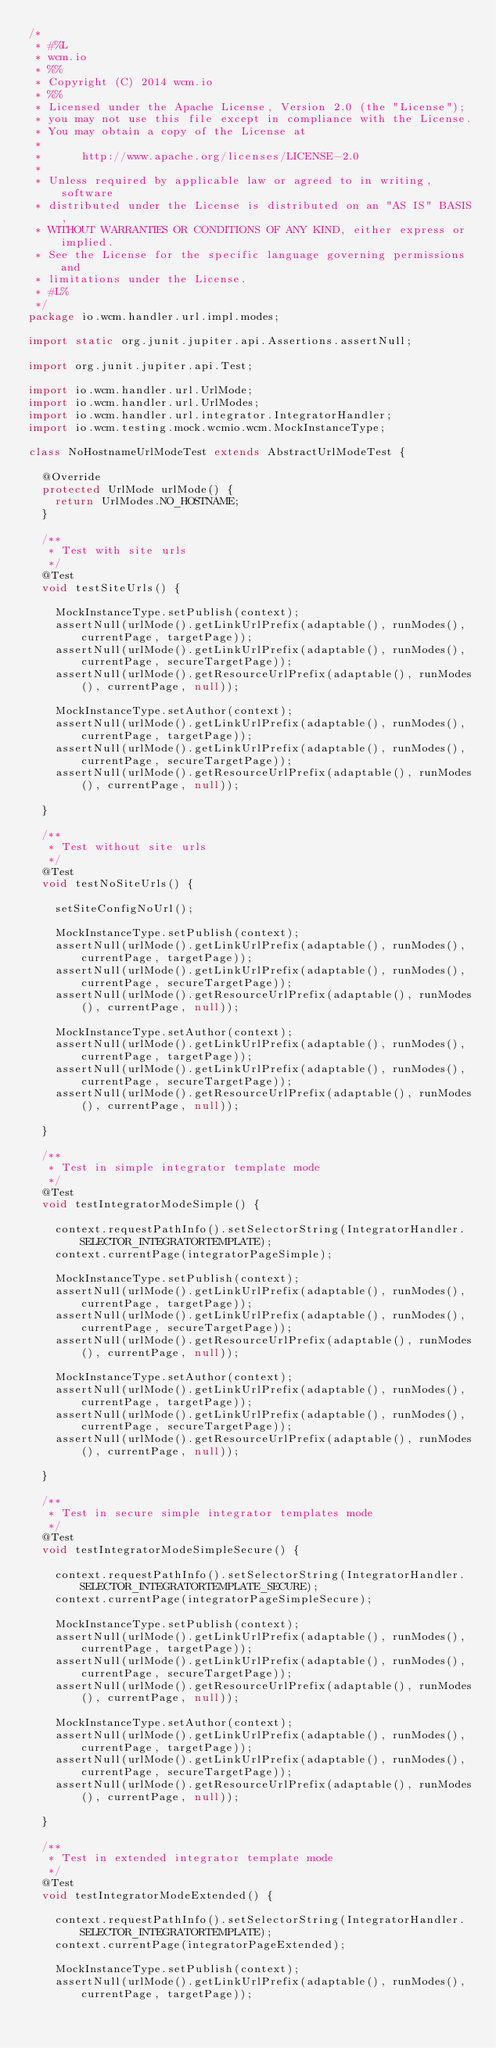Convert code to text. <code><loc_0><loc_0><loc_500><loc_500><_Java_>/*
 * #%L
 * wcm.io
 * %%
 * Copyright (C) 2014 wcm.io
 * %%
 * Licensed under the Apache License, Version 2.0 (the "License");
 * you may not use this file except in compliance with the License.
 * You may obtain a copy of the License at
 *
 *      http://www.apache.org/licenses/LICENSE-2.0
 *
 * Unless required by applicable law or agreed to in writing, software
 * distributed under the License is distributed on an "AS IS" BASIS,
 * WITHOUT WARRANTIES OR CONDITIONS OF ANY KIND, either express or implied.
 * See the License for the specific language governing permissions and
 * limitations under the License.
 * #L%
 */
package io.wcm.handler.url.impl.modes;

import static org.junit.jupiter.api.Assertions.assertNull;

import org.junit.jupiter.api.Test;

import io.wcm.handler.url.UrlMode;
import io.wcm.handler.url.UrlModes;
import io.wcm.handler.url.integrator.IntegratorHandler;
import io.wcm.testing.mock.wcmio.wcm.MockInstanceType;

class NoHostnameUrlModeTest extends AbstractUrlModeTest {

  @Override
  protected UrlMode urlMode() {
    return UrlModes.NO_HOSTNAME;
  }

  /**
   * Test with site urls
   */
  @Test
  void testSiteUrls() {

    MockInstanceType.setPublish(context);
    assertNull(urlMode().getLinkUrlPrefix(adaptable(), runModes(), currentPage, targetPage));
    assertNull(urlMode().getLinkUrlPrefix(adaptable(), runModes(), currentPage, secureTargetPage));
    assertNull(urlMode().getResourceUrlPrefix(adaptable(), runModes(), currentPage, null));

    MockInstanceType.setAuthor(context);
    assertNull(urlMode().getLinkUrlPrefix(adaptable(), runModes(), currentPage, targetPage));
    assertNull(urlMode().getLinkUrlPrefix(adaptable(), runModes(), currentPage, secureTargetPage));
    assertNull(urlMode().getResourceUrlPrefix(adaptable(), runModes(), currentPage, null));

  }

  /**
   * Test without site urls
   */
  @Test
  void testNoSiteUrls() {

    setSiteConfigNoUrl();

    MockInstanceType.setPublish(context);
    assertNull(urlMode().getLinkUrlPrefix(adaptable(), runModes(), currentPage, targetPage));
    assertNull(urlMode().getLinkUrlPrefix(adaptable(), runModes(), currentPage, secureTargetPage));
    assertNull(urlMode().getResourceUrlPrefix(adaptable(), runModes(), currentPage, null));

    MockInstanceType.setAuthor(context);
    assertNull(urlMode().getLinkUrlPrefix(adaptable(), runModes(), currentPage, targetPage));
    assertNull(urlMode().getLinkUrlPrefix(adaptable(), runModes(), currentPage, secureTargetPage));
    assertNull(urlMode().getResourceUrlPrefix(adaptable(), runModes(), currentPage, null));

  }

  /**
   * Test in simple integrator template mode
   */
  @Test
  void testIntegratorModeSimple() {

    context.requestPathInfo().setSelectorString(IntegratorHandler.SELECTOR_INTEGRATORTEMPLATE);
    context.currentPage(integratorPageSimple);

    MockInstanceType.setPublish(context);
    assertNull(urlMode().getLinkUrlPrefix(adaptable(), runModes(), currentPage, targetPage));
    assertNull(urlMode().getLinkUrlPrefix(adaptable(), runModes(), currentPage, secureTargetPage));
    assertNull(urlMode().getResourceUrlPrefix(adaptable(), runModes(), currentPage, null));

    MockInstanceType.setAuthor(context);
    assertNull(urlMode().getLinkUrlPrefix(adaptable(), runModes(), currentPage, targetPage));
    assertNull(urlMode().getLinkUrlPrefix(adaptable(), runModes(), currentPage, secureTargetPage));
    assertNull(urlMode().getResourceUrlPrefix(adaptable(), runModes(), currentPage, null));

  }

  /**
   * Test in secure simple integrator templates mode
   */
  @Test
  void testIntegratorModeSimpleSecure() {

    context.requestPathInfo().setSelectorString(IntegratorHandler.SELECTOR_INTEGRATORTEMPLATE_SECURE);
    context.currentPage(integratorPageSimpleSecure);

    MockInstanceType.setPublish(context);
    assertNull(urlMode().getLinkUrlPrefix(adaptable(), runModes(), currentPage, targetPage));
    assertNull(urlMode().getLinkUrlPrefix(adaptable(), runModes(), currentPage, secureTargetPage));
    assertNull(urlMode().getResourceUrlPrefix(adaptable(), runModes(), currentPage, null));

    MockInstanceType.setAuthor(context);
    assertNull(urlMode().getLinkUrlPrefix(adaptable(), runModes(), currentPage, targetPage));
    assertNull(urlMode().getLinkUrlPrefix(adaptable(), runModes(), currentPage, secureTargetPage));
    assertNull(urlMode().getResourceUrlPrefix(adaptable(), runModes(), currentPage, null));

  }

  /**
   * Test in extended integrator template mode
   */
  @Test
  void testIntegratorModeExtended() {

    context.requestPathInfo().setSelectorString(IntegratorHandler.SELECTOR_INTEGRATORTEMPLATE);
    context.currentPage(integratorPageExtended);

    MockInstanceType.setPublish(context);
    assertNull(urlMode().getLinkUrlPrefix(adaptable(), runModes(), currentPage, targetPage));</code> 